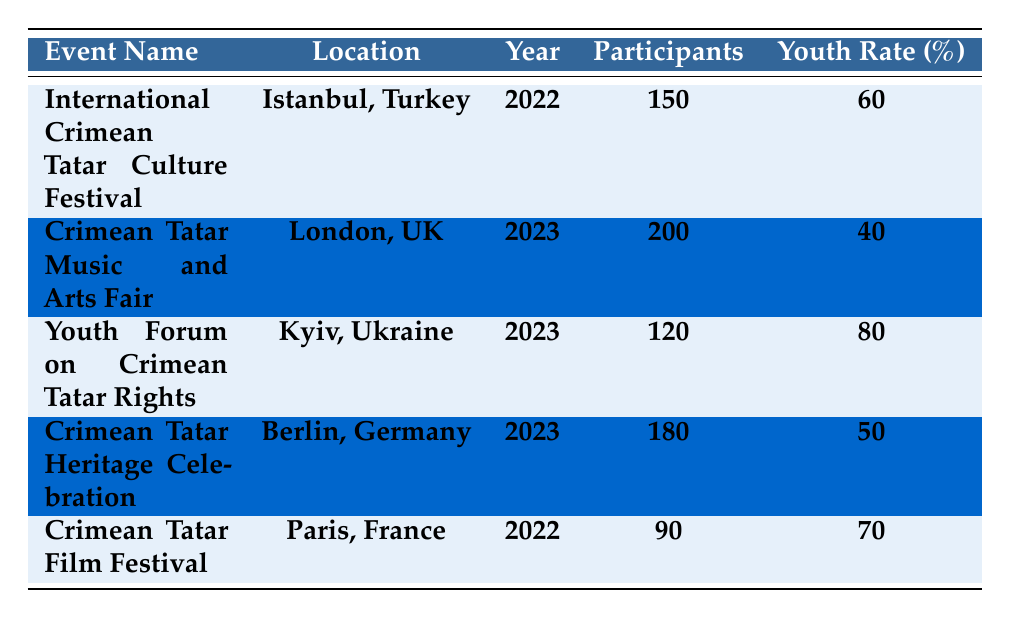What is the youth participation rate for the International Crimean Tatar Culture Festival? The table shows that the youth participation rate for the International Crimean Tatar Culture Festival in 2022 is 60%.
Answer: 60% Which event had the highest number of participants? The table indicates that the Crimean Tatar Music and Arts Fair had the highest number of participants, totaling 200 in 2023.
Answer: 200 What is the youth participation rate for the Crimean Tatar Film Festival? According to the table, the youth participation rate for the Crimean Tatar Film Festival in 2022 is 70%.
Answer: 70% Which event took place in 2023 and had a youth participation rate of 80%? The table shows that the Youth Forum on Crimean Tatar Rights took place in 2023 and had a youth participation rate of 80%.
Answer: Youth Forum on Crimean Tatar Rights Calculate the average youth participation rate across all events listed. To find the average youth participation rate, first add all the rates: 60 + 40 + 80 + 50 + 70 = 300. There are 5 events, so the average is 300/5 = 60.
Answer: 60 Is the youth participation rate for the Crimean Tatar Heritage Celebration greater than 50%? The table states that the youth participation rate for the Crimean Tatar Heritage Celebration is 50%, so it is not greater.
Answer: No Which event had a youth participation rate lower than 50%? The table indicates that the Crimean Tatar Music and Arts Fair had a youth participation rate of 40%, which is lower than 50%.
Answer: Crimean Tatar Music and Arts Fair What is the total number of participants across all events in 2022? For 2022, there are two events: the International Crimean Tatar Culture Festival with 150 participants and the Crimean Tatar Film Festival with 90 participants. Adding these gives 150 + 90 = 240.
Answer: 240 Which city hosted the event with the lowest youth participation rate? The Crimean Tatar Music and Arts Fair in London, UK, had the lowest youth participation rate of 40%.
Answer: London If a new event with 100 participants also has a youth participation rate of 60%, how would this affect the average youth participation rate calculated earlier? The new event would add 100 participants and a youth rate of 60% to the existing total. The total participant count becomes 500 (from 400 + 100) and the new youth participation rate would be (300 + (0.6*100))/5 = 60. So, the average remains unchanged.
Answer: No change 